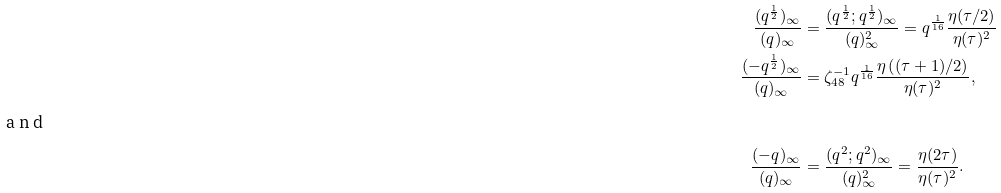Convert formula to latex. <formula><loc_0><loc_0><loc_500><loc_500>\frac { ( q ^ { \frac { 1 } { 2 } } ) _ { \infty } } { ( q ) _ { \infty } } & = \frac { ( q ^ { \frac { 1 } { 2 } } ; q ^ { \frac { 1 } { 2 } } ) _ { \infty } } { ( q ) _ { \infty } ^ { 2 } } = q ^ { \frac { 1 } { 1 6 } } \frac { \eta ( \tau / 2 ) } { \eta ( \tau ) ^ { 2 } } \\ \frac { ( - q ^ { \frac { 1 } { 2 } } ) _ { \infty } } { ( q ) _ { \infty } } & = \zeta _ { 4 8 } ^ { - 1 } q ^ { \frac { 1 } { 1 6 } } \frac { \eta \left ( ( \tau + 1 ) / 2 \right ) } { \eta ( \tau ) ^ { 2 } } , \\ \intertext { a n d } \frac { ( - q ) _ { \infty } } { ( q ) _ { \infty } } & = \frac { ( q ^ { 2 } ; q ^ { 2 } ) _ { \infty } } { ( q ) _ { \infty } ^ { 2 } } = \frac { \eta ( 2 \tau ) } { \eta ( \tau ) ^ { 2 } } .</formula> 